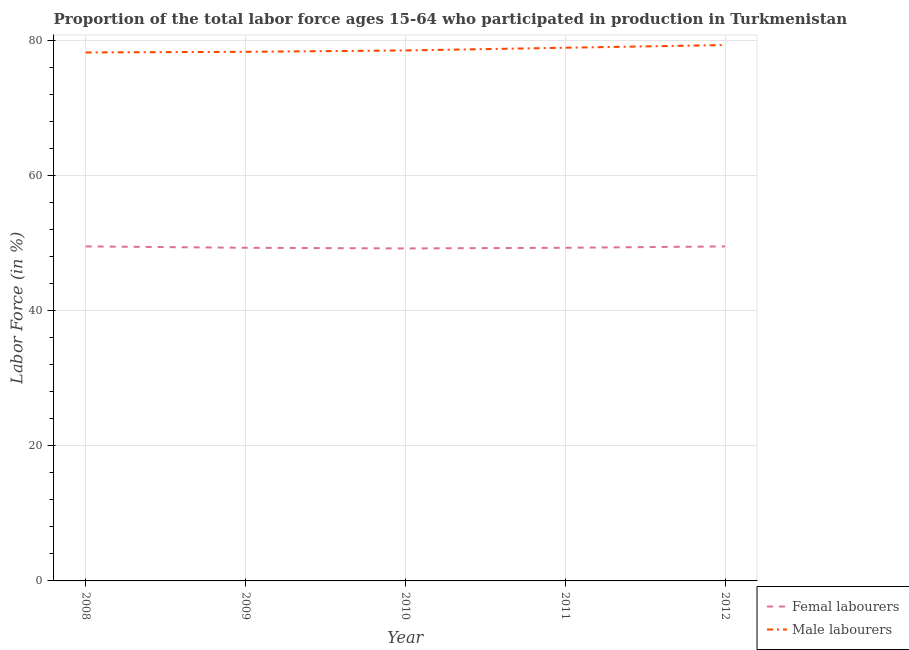How many different coloured lines are there?
Make the answer very short. 2. Does the line corresponding to percentage of female labor force intersect with the line corresponding to percentage of male labour force?
Offer a terse response. No. What is the percentage of female labor force in 2012?
Offer a very short reply. 49.5. Across all years, what is the maximum percentage of male labour force?
Provide a succinct answer. 79.3. Across all years, what is the minimum percentage of male labour force?
Your answer should be very brief. 78.2. In which year was the percentage of male labour force minimum?
Offer a very short reply. 2008. What is the total percentage of female labor force in the graph?
Offer a terse response. 246.8. What is the difference between the percentage of male labour force in 2010 and that in 2011?
Provide a short and direct response. -0.4. What is the difference between the percentage of male labour force in 2010 and the percentage of female labor force in 2011?
Provide a succinct answer. 29.2. What is the average percentage of male labour force per year?
Ensure brevity in your answer.  78.64. In the year 2009, what is the difference between the percentage of female labor force and percentage of male labour force?
Ensure brevity in your answer.  -29. What is the ratio of the percentage of female labor force in 2011 to that in 2012?
Provide a succinct answer. 1. Is the percentage of female labor force in 2010 less than that in 2012?
Give a very brief answer. Yes. Is the difference between the percentage of female labor force in 2008 and 2010 greater than the difference between the percentage of male labour force in 2008 and 2010?
Give a very brief answer. Yes. What is the difference between the highest and the second highest percentage of female labor force?
Keep it short and to the point. 0. What is the difference between the highest and the lowest percentage of male labour force?
Your response must be concise. 1.1. Is the sum of the percentage of female labor force in 2008 and 2011 greater than the maximum percentage of male labour force across all years?
Your response must be concise. Yes. How many years are there in the graph?
Your response must be concise. 5. Are the values on the major ticks of Y-axis written in scientific E-notation?
Give a very brief answer. No. Does the graph contain any zero values?
Your response must be concise. No. Does the graph contain grids?
Make the answer very short. Yes. How many legend labels are there?
Offer a terse response. 2. How are the legend labels stacked?
Keep it short and to the point. Vertical. What is the title of the graph?
Offer a terse response. Proportion of the total labor force ages 15-64 who participated in production in Turkmenistan. Does "Pregnant women" appear as one of the legend labels in the graph?
Offer a very short reply. No. What is the Labor Force (in %) of Femal labourers in 2008?
Your answer should be compact. 49.5. What is the Labor Force (in %) in Male labourers in 2008?
Offer a very short reply. 78.2. What is the Labor Force (in %) of Femal labourers in 2009?
Ensure brevity in your answer.  49.3. What is the Labor Force (in %) of Male labourers in 2009?
Give a very brief answer. 78.3. What is the Labor Force (in %) of Femal labourers in 2010?
Provide a short and direct response. 49.2. What is the Labor Force (in %) in Male labourers in 2010?
Your answer should be very brief. 78.5. What is the Labor Force (in %) of Femal labourers in 2011?
Your answer should be very brief. 49.3. What is the Labor Force (in %) in Male labourers in 2011?
Offer a terse response. 78.9. What is the Labor Force (in %) in Femal labourers in 2012?
Your answer should be compact. 49.5. What is the Labor Force (in %) in Male labourers in 2012?
Keep it short and to the point. 79.3. Across all years, what is the maximum Labor Force (in %) of Femal labourers?
Give a very brief answer. 49.5. Across all years, what is the maximum Labor Force (in %) in Male labourers?
Offer a very short reply. 79.3. Across all years, what is the minimum Labor Force (in %) in Femal labourers?
Your answer should be compact. 49.2. Across all years, what is the minimum Labor Force (in %) in Male labourers?
Make the answer very short. 78.2. What is the total Labor Force (in %) in Femal labourers in the graph?
Make the answer very short. 246.8. What is the total Labor Force (in %) of Male labourers in the graph?
Make the answer very short. 393.2. What is the difference between the Labor Force (in %) in Femal labourers in 2008 and that in 2009?
Your response must be concise. 0.2. What is the difference between the Labor Force (in %) in Male labourers in 2008 and that in 2009?
Ensure brevity in your answer.  -0.1. What is the difference between the Labor Force (in %) of Femal labourers in 2008 and that in 2010?
Your response must be concise. 0.3. What is the difference between the Labor Force (in %) in Male labourers in 2008 and that in 2010?
Your answer should be compact. -0.3. What is the difference between the Labor Force (in %) of Femal labourers in 2008 and that in 2011?
Your answer should be compact. 0.2. What is the difference between the Labor Force (in %) of Male labourers in 2008 and that in 2011?
Ensure brevity in your answer.  -0.7. What is the difference between the Labor Force (in %) in Femal labourers in 2008 and that in 2012?
Your answer should be very brief. 0. What is the difference between the Labor Force (in %) in Male labourers in 2008 and that in 2012?
Provide a short and direct response. -1.1. What is the difference between the Labor Force (in %) in Femal labourers in 2009 and that in 2010?
Give a very brief answer. 0.1. What is the difference between the Labor Force (in %) in Femal labourers in 2009 and that in 2011?
Ensure brevity in your answer.  0. What is the difference between the Labor Force (in %) in Femal labourers in 2009 and that in 2012?
Keep it short and to the point. -0.2. What is the difference between the Labor Force (in %) in Male labourers in 2010 and that in 2012?
Make the answer very short. -0.8. What is the difference between the Labor Force (in %) in Femal labourers in 2008 and the Labor Force (in %) in Male labourers in 2009?
Give a very brief answer. -28.8. What is the difference between the Labor Force (in %) of Femal labourers in 2008 and the Labor Force (in %) of Male labourers in 2010?
Give a very brief answer. -29. What is the difference between the Labor Force (in %) of Femal labourers in 2008 and the Labor Force (in %) of Male labourers in 2011?
Ensure brevity in your answer.  -29.4. What is the difference between the Labor Force (in %) of Femal labourers in 2008 and the Labor Force (in %) of Male labourers in 2012?
Your answer should be compact. -29.8. What is the difference between the Labor Force (in %) in Femal labourers in 2009 and the Labor Force (in %) in Male labourers in 2010?
Offer a terse response. -29.2. What is the difference between the Labor Force (in %) in Femal labourers in 2009 and the Labor Force (in %) in Male labourers in 2011?
Keep it short and to the point. -29.6. What is the difference between the Labor Force (in %) in Femal labourers in 2010 and the Labor Force (in %) in Male labourers in 2011?
Keep it short and to the point. -29.7. What is the difference between the Labor Force (in %) of Femal labourers in 2010 and the Labor Force (in %) of Male labourers in 2012?
Your response must be concise. -30.1. What is the difference between the Labor Force (in %) in Femal labourers in 2011 and the Labor Force (in %) in Male labourers in 2012?
Your answer should be compact. -30. What is the average Labor Force (in %) in Femal labourers per year?
Offer a terse response. 49.36. What is the average Labor Force (in %) of Male labourers per year?
Ensure brevity in your answer.  78.64. In the year 2008, what is the difference between the Labor Force (in %) of Femal labourers and Labor Force (in %) of Male labourers?
Offer a very short reply. -28.7. In the year 2010, what is the difference between the Labor Force (in %) in Femal labourers and Labor Force (in %) in Male labourers?
Make the answer very short. -29.3. In the year 2011, what is the difference between the Labor Force (in %) in Femal labourers and Labor Force (in %) in Male labourers?
Offer a very short reply. -29.6. In the year 2012, what is the difference between the Labor Force (in %) of Femal labourers and Labor Force (in %) of Male labourers?
Offer a terse response. -29.8. What is the ratio of the Labor Force (in %) of Femal labourers in 2008 to that in 2010?
Provide a succinct answer. 1.01. What is the ratio of the Labor Force (in %) of Male labourers in 2008 to that in 2010?
Your response must be concise. 1. What is the ratio of the Labor Force (in %) in Femal labourers in 2008 to that in 2011?
Make the answer very short. 1. What is the ratio of the Labor Force (in %) in Male labourers in 2008 to that in 2012?
Offer a terse response. 0.99. What is the ratio of the Labor Force (in %) in Femal labourers in 2009 to that in 2010?
Give a very brief answer. 1. What is the ratio of the Labor Force (in %) in Male labourers in 2009 to that in 2011?
Offer a very short reply. 0.99. What is the ratio of the Labor Force (in %) in Femal labourers in 2009 to that in 2012?
Give a very brief answer. 1. What is the ratio of the Labor Force (in %) in Male labourers in 2009 to that in 2012?
Provide a succinct answer. 0.99. What is the ratio of the Labor Force (in %) in Male labourers in 2010 to that in 2011?
Ensure brevity in your answer.  0.99. What is the ratio of the Labor Force (in %) in Femal labourers in 2010 to that in 2012?
Give a very brief answer. 0.99. What is the difference between the highest and the second highest Labor Force (in %) in Male labourers?
Keep it short and to the point. 0.4. What is the difference between the highest and the lowest Labor Force (in %) of Male labourers?
Your answer should be very brief. 1.1. 